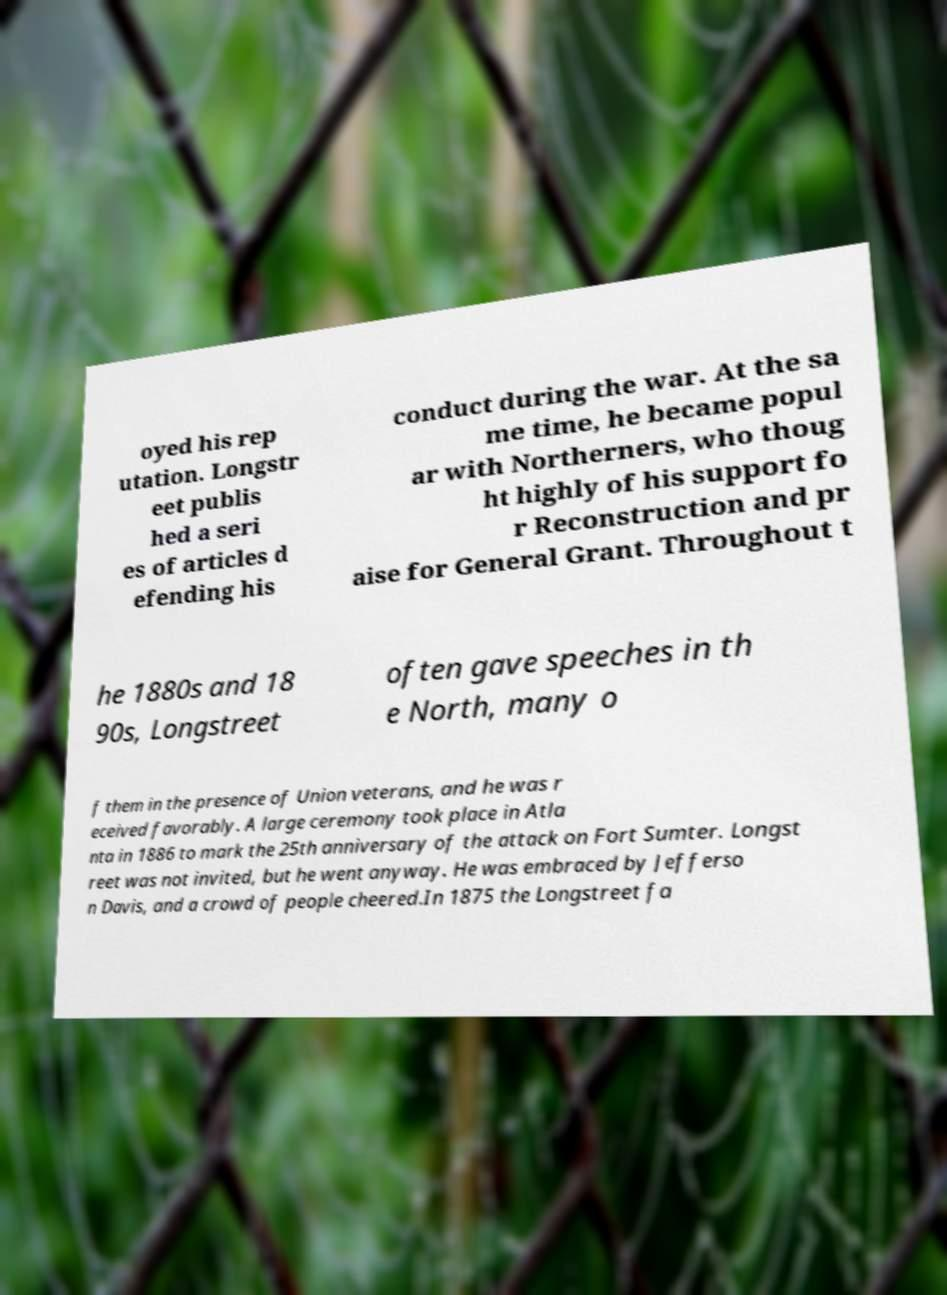Can you accurately transcribe the text from the provided image for me? oyed his rep utation. Longstr eet publis hed a seri es of articles d efending his conduct during the war. At the sa me time, he became popul ar with Northerners, who thoug ht highly of his support fo r Reconstruction and pr aise for General Grant. Throughout t he 1880s and 18 90s, Longstreet often gave speeches in th e North, many o f them in the presence of Union veterans, and he was r eceived favorably. A large ceremony took place in Atla nta in 1886 to mark the 25th anniversary of the attack on Fort Sumter. Longst reet was not invited, but he went anyway. He was embraced by Jefferso n Davis, and a crowd of people cheered.In 1875 the Longstreet fa 